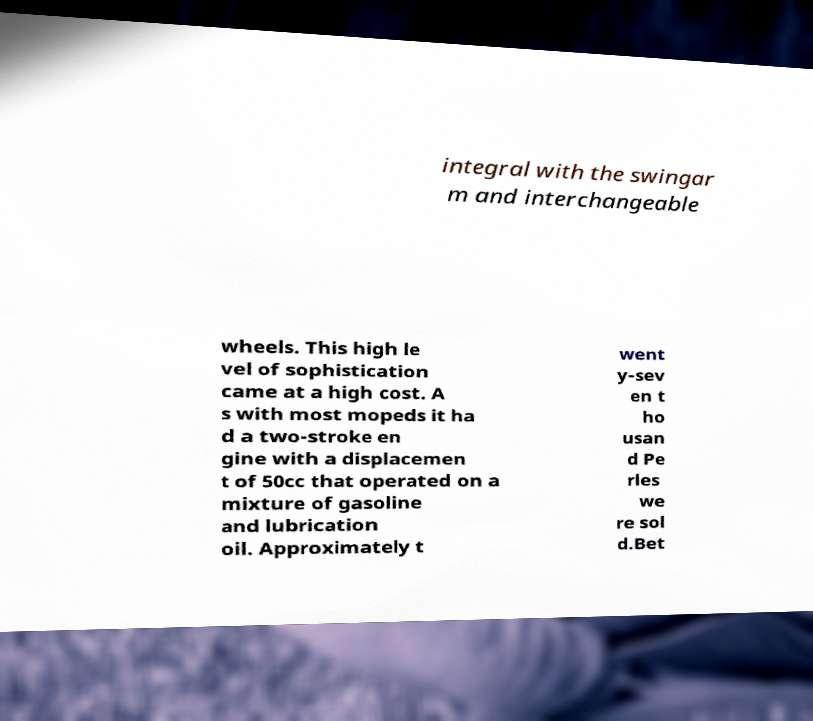Could you extract and type out the text from this image? integral with the swingar m and interchangeable wheels. This high le vel of sophistication came at a high cost. A s with most mopeds it ha d a two-stroke en gine with a displacemen t of 50cc that operated on a mixture of gasoline and lubrication oil. Approximately t went y-sev en t ho usan d Pe rles we re sol d.Bet 